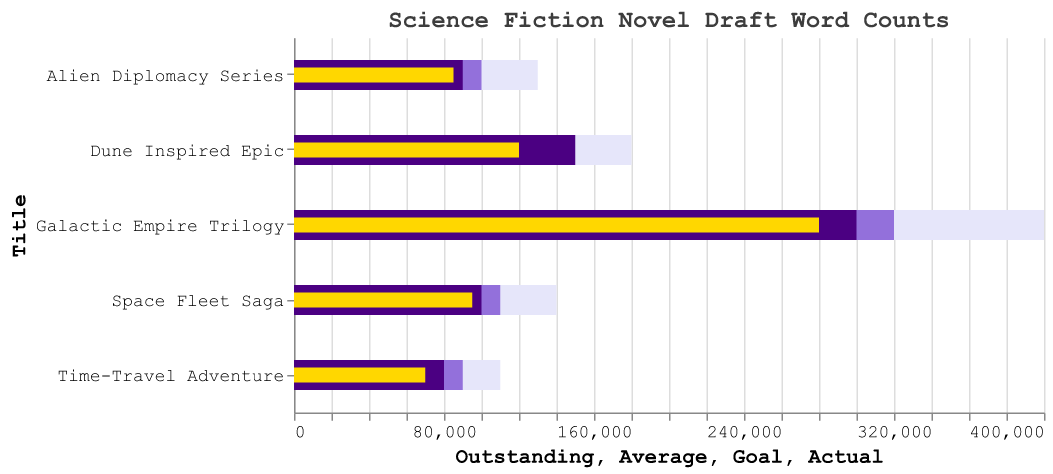How many titles are displayed in the chart? By observing the number of distinct bars representing the different titles, we can count the total.
Answer: 5 Which novel draft has the highest actual word count? By comparing the gold-colored bars representing the actual word counts, the longest bar corresponds to the "Galactic Empire Trilogy".
Answer: Galactic Empire Trilogy How many words short is the "Dune Inspired Epic" from its goal? The goal for "Dune Inspired Epic" is shown as a dark indigo bar of 150,000 words, and the actual is a gold bar of 120,000 words. Subtracting the actual from the goal gives 150,000 - 120,000.
Answer: 30,000 Which title has the largest gap between its average and outstanding word count? The largest gap appears where the difference between the lavender-colored bar (Outstanding) and the light purple-colored bar (Average) is the most significant. The "Galactic Empire Trilogy" shows a difference of 400,000 - 320,000.
Answer: Galactic Empire Trilogy What is the difference between the goal and the actual word counts for "Space Fleet Saga"? The goal is 100,000 words, and the actual is 95,000 words. Subtracting these values results in 100,000 - 95,000.
Answer: 5,000 Among the listed titles, which one has the closest actual word count to its average word count? By comparing the gold and purple bars for each title, the closest match is where the bars nearly overlap. "Alien Diplomacy Series" has actual 85,000 and average 100,000, showing a 15,000 words difference.
Answer: Alien Diplomacy Series Rank the titles from the highest to the lowest actual word counts. By examining the lengths of the gold bars, we rank each one: Galactic Empire Trilogy (280,000), Dune Inspired Epic (120,000), Space Fleet Saga (95,000), Alien Diplomacy Series (85,000), Time-Travel Adventure (70,000).
Answer: Galactic Empire Trilogy, Dune Inspired Epic, Space Fleet Saga, Alien Diplomacy Series, Time-Travel Adventure What is the average word count goal across all titles? Sum the goals of all titles and divide by the number of titles: (150,000 + 100,000 + 90,000 + 300,000 + 80,000) / 5, which simplifies to 720,000 / 5.
Answer: 144,000 Which novel draft has an outstanding word count that is more than three times its actual word count? Examine the relationship between the lavender-colored (Outstanding) and gold-colored (Actual) bars. For "Time-Travel Adventure", Outstanding (110,000) is more than thrice its Actual (70,000).
Answer: Time-Travel Adventure 